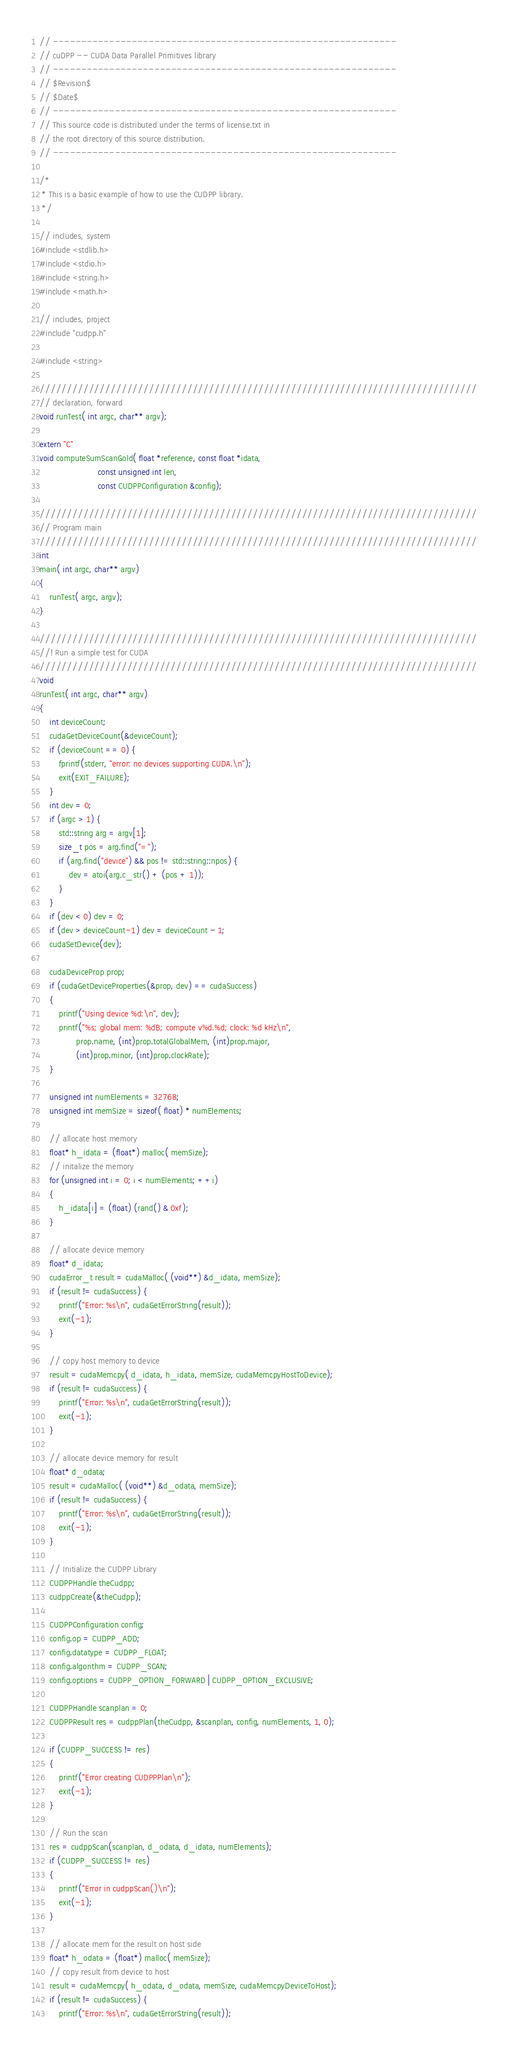<code> <loc_0><loc_0><loc_500><loc_500><_Cuda_>// -------------------------------------------------------------
// cuDPP -- CUDA Data Parallel Primitives library
// -------------------------------------------------------------
// $Revision$
// $Date$
// ------------------------------------------------------------- 
// This source code is distributed under the terms of license.txt in
// the root directory of this source distribution.
// ------------------------------------------------------------- 

/*
 * This is a basic example of how to use the CUDPP library.
 */

// includes, system
#include <stdlib.h>
#include <stdio.h>
#include <string.h>
#include <math.h>

// includes, project
#include "cudpp.h"

#include <string>

////////////////////////////////////////////////////////////////////////////////
// declaration, forward
void runTest( int argc, char** argv);

extern "C" 
void computeSumScanGold( float *reference, const float *idata, 
                        const unsigned int len,
                        const CUDPPConfiguration &config);

////////////////////////////////////////////////////////////////////////////////
// Program main
////////////////////////////////////////////////////////////////////////////////
int
main( int argc, char** argv) 
{
    runTest( argc, argv);
}

////////////////////////////////////////////////////////////////////////////////
//! Run a simple test for CUDA
////////////////////////////////////////////////////////////////////////////////
void
runTest( int argc, char** argv) 
{
    int deviceCount;
    cudaGetDeviceCount(&deviceCount);
    if (deviceCount == 0) {
        fprintf(stderr, "error: no devices supporting CUDA.\n");
        exit(EXIT_FAILURE);
    }
    int dev = 0;
    if (argc > 1) {
        std::string arg = argv[1];
        size_t pos = arg.find("=");
        if (arg.find("device") && pos != std::string::npos) {
            dev = atoi(arg.c_str() + (pos + 1));
        }
    }
    if (dev < 0) dev = 0;
    if (dev > deviceCount-1) dev = deviceCount - 1;
    cudaSetDevice(dev);

    cudaDeviceProp prop;
    if (cudaGetDeviceProperties(&prop, dev) == cudaSuccess)
    {
        printf("Using device %d:\n", dev);
        printf("%s; global mem: %dB; compute v%d.%d; clock: %d kHz\n",
               prop.name, (int)prop.totalGlobalMem, (int)prop.major, 
               (int)prop.minor, (int)prop.clockRate);
    }

    unsigned int numElements = 32768;
    unsigned int memSize = sizeof( float) * numElements;

    // allocate host memory
    float* h_idata = (float*) malloc( memSize);
    // initalize the memory
    for (unsigned int i = 0; i < numElements; ++i) 
    {
        h_idata[i] = (float) (rand() & 0xf);
    }

    // allocate device memory
    float* d_idata;
    cudaError_t result = cudaMalloc( (void**) &d_idata, memSize);
    if (result != cudaSuccess) {
        printf("Error: %s\n", cudaGetErrorString(result));
        exit(-1);
    }
    
    // copy host memory to device
    result = cudaMemcpy( d_idata, h_idata, memSize, cudaMemcpyHostToDevice);
    if (result != cudaSuccess) {
        printf("Error: %s\n", cudaGetErrorString(result));
        exit(-1);
    }
     
    // allocate device memory for result
    float* d_odata;
    result = cudaMalloc( (void**) &d_odata, memSize);
    if (result != cudaSuccess) {
        printf("Error: %s\n", cudaGetErrorString(result));
        exit(-1);
    }

    // Initialize the CUDPP Library
    CUDPPHandle theCudpp;
    cudppCreate(&theCudpp);

    CUDPPConfiguration config;
    config.op = CUDPP_ADD;
    config.datatype = CUDPP_FLOAT;
    config.algorithm = CUDPP_SCAN;
    config.options = CUDPP_OPTION_FORWARD | CUDPP_OPTION_EXCLUSIVE;
    
    CUDPPHandle scanplan = 0;
    CUDPPResult res = cudppPlan(theCudpp, &scanplan, config, numElements, 1, 0);  

    if (CUDPP_SUCCESS != res)
    {
        printf("Error creating CUDPPPlan\n");
        exit(-1);
    }

    // Run the scan
    res = cudppScan(scanplan, d_odata, d_idata, numElements);
    if (CUDPP_SUCCESS != res)
    {
        printf("Error in cudppScan()\n");
        exit(-1);
    }

    // allocate mem for the result on host side
    float* h_odata = (float*) malloc( memSize);
    // copy result from device to host
    result = cudaMemcpy( h_odata, d_odata, memSize, cudaMemcpyDeviceToHost);
    if (result != cudaSuccess) {
        printf("Error: %s\n", cudaGetErrorString(result));</code> 